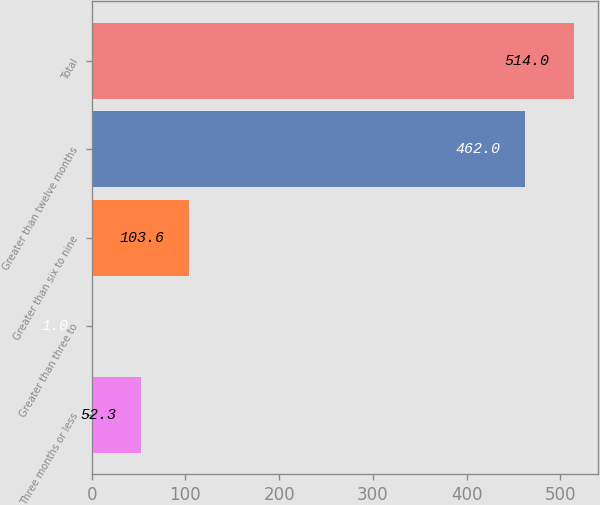Convert chart. <chart><loc_0><loc_0><loc_500><loc_500><bar_chart><fcel>Three months or less<fcel>Greater than three to<fcel>Greater than six to nine<fcel>Greater than twelve months<fcel>Total<nl><fcel>52.3<fcel>1<fcel>103.6<fcel>462<fcel>514<nl></chart> 